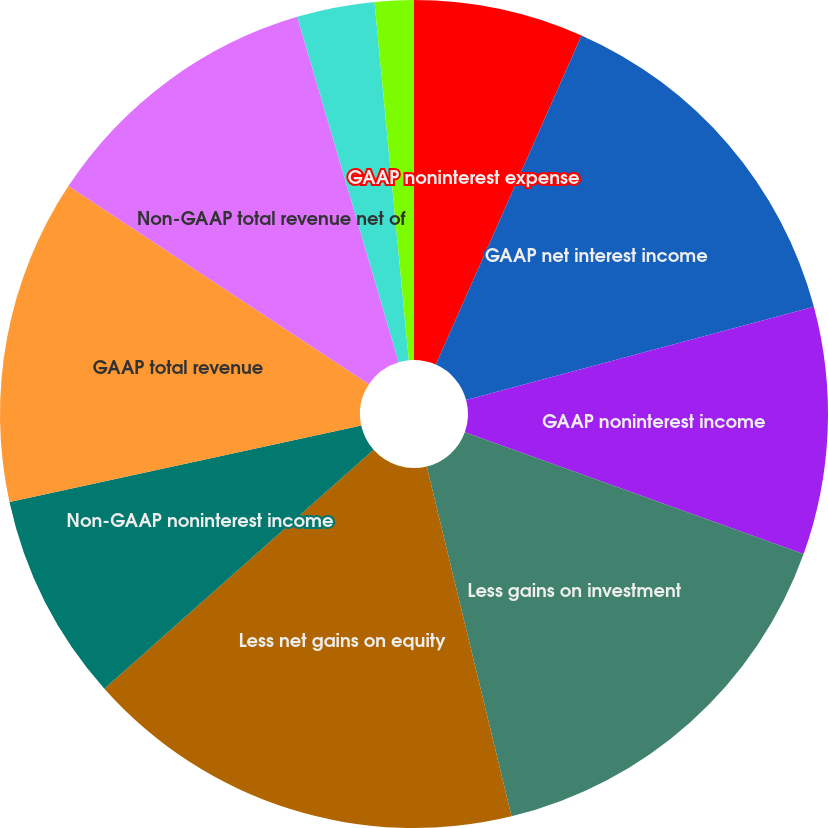Convert chart. <chart><loc_0><loc_0><loc_500><loc_500><pie_chart><fcel>GAAP noninterest expense<fcel>GAAP net interest income<fcel>GAAP noninterest income<fcel>Less gains on investment<fcel>Less net gains on equity<fcel>Non-GAAP noninterest income<fcel>GAAP total revenue<fcel>Non-GAAP total revenue net of<fcel>GAAP operating efficiency<fcel>Non-GAAP core operating<nl><fcel>6.63%<fcel>14.2%<fcel>9.66%<fcel>15.72%<fcel>17.23%<fcel>8.14%<fcel>12.69%<fcel>11.17%<fcel>3.03%<fcel>1.52%<nl></chart> 